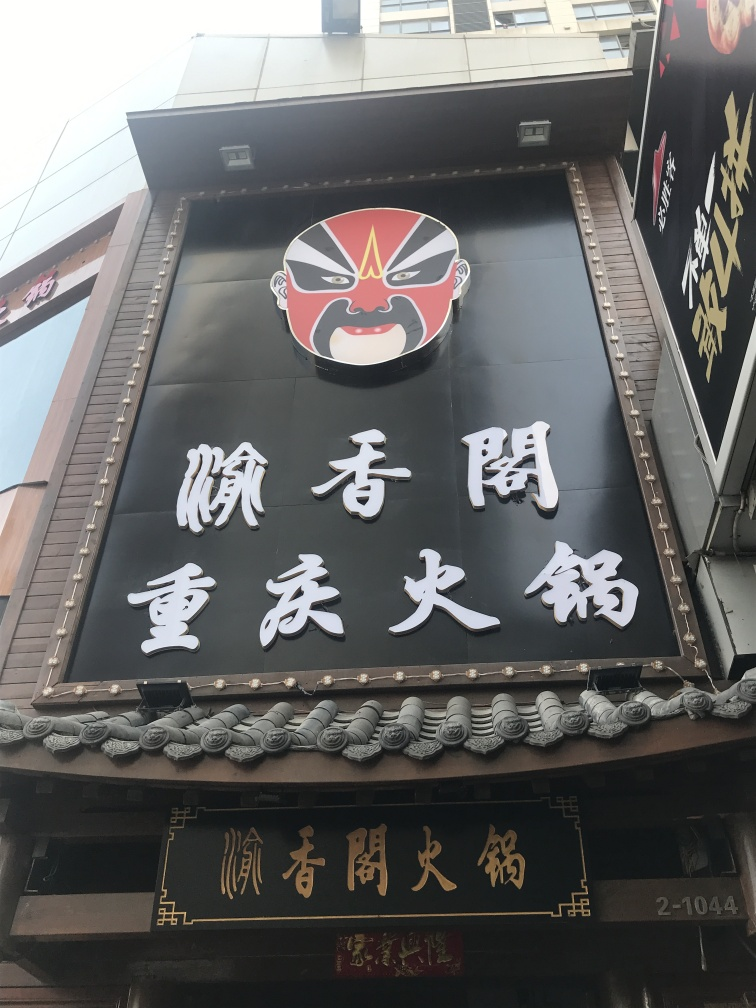Can you describe the design elements present on this signage? Certainly! This signage contains bold calligraphic text juxtaposed upon a black background, accompanied by a graphic that resembles a mask typically seen in Noh or Kabuki theatre, indicating an artistic or theatrical theme. Additionally, the intricate border design below the sign has a traditional aesthetic that echoes architectural embellishments found in East Asian design. 